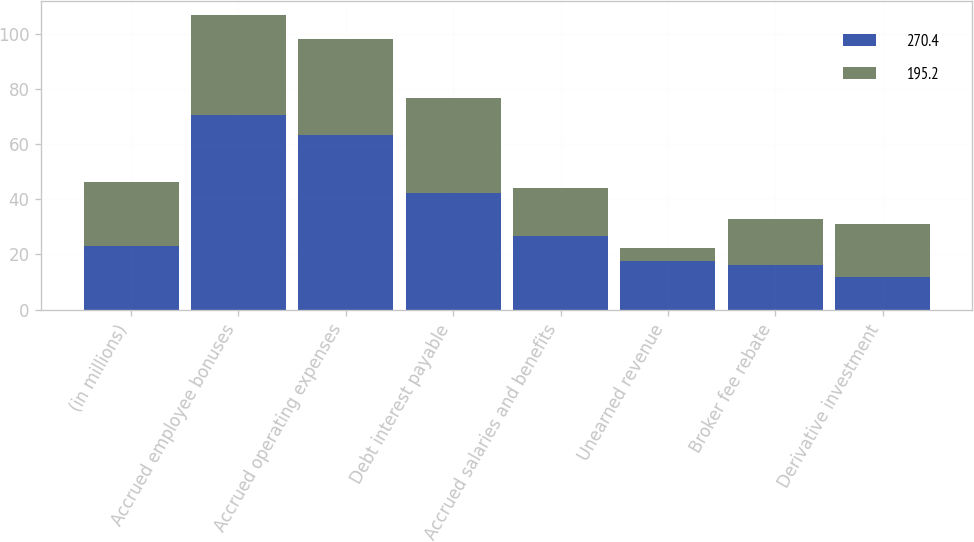Convert chart. <chart><loc_0><loc_0><loc_500><loc_500><stacked_bar_chart><ecel><fcel>(in millions)<fcel>Accrued employee bonuses<fcel>Accrued operating expenses<fcel>Debt interest payable<fcel>Accrued salaries and benefits<fcel>Unearned revenue<fcel>Broker fee rebate<fcel>Derivative investment<nl><fcel>270.4<fcel>23.05<fcel>70.7<fcel>63.3<fcel>42.1<fcel>26.8<fcel>17.6<fcel>16.3<fcel>11.8<nl><fcel>195.2<fcel>23.05<fcel>35.9<fcel>34.7<fcel>34.6<fcel>17.4<fcel>4.9<fcel>16.4<fcel>19.3<nl></chart> 